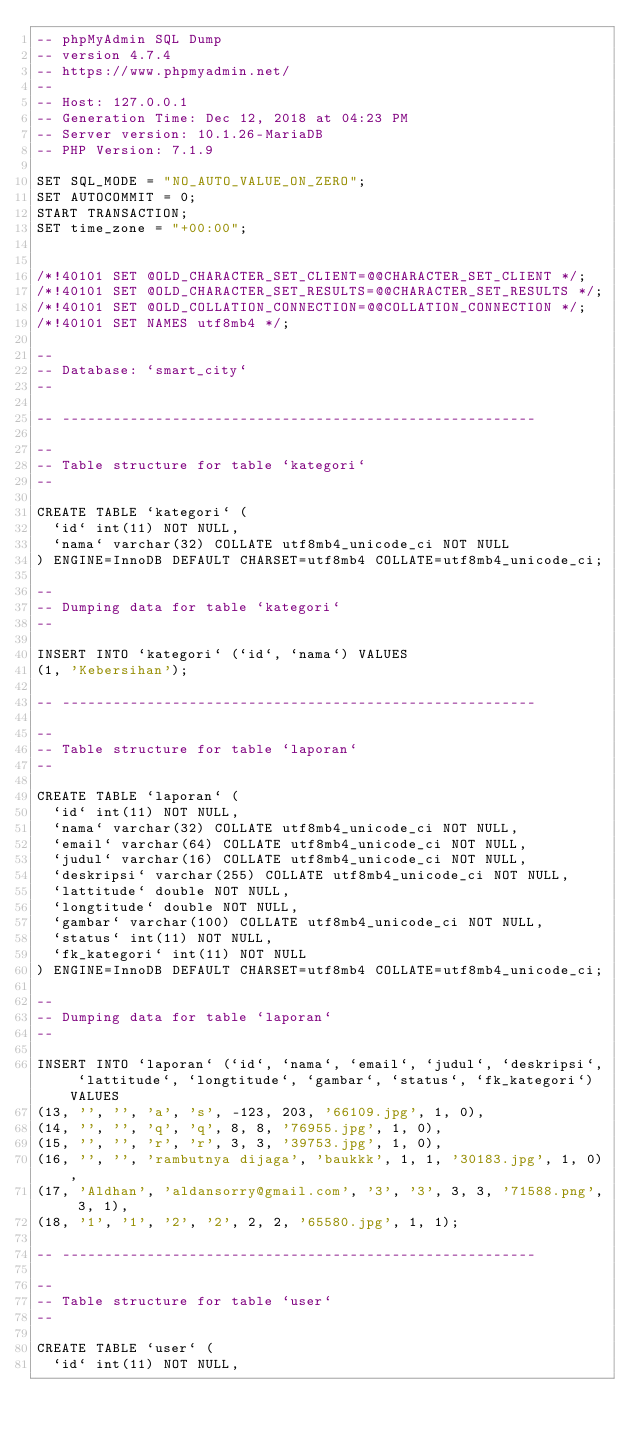Convert code to text. <code><loc_0><loc_0><loc_500><loc_500><_SQL_>-- phpMyAdmin SQL Dump
-- version 4.7.4
-- https://www.phpmyadmin.net/
--
-- Host: 127.0.0.1
-- Generation Time: Dec 12, 2018 at 04:23 PM
-- Server version: 10.1.26-MariaDB
-- PHP Version: 7.1.9

SET SQL_MODE = "NO_AUTO_VALUE_ON_ZERO";
SET AUTOCOMMIT = 0;
START TRANSACTION;
SET time_zone = "+00:00";


/*!40101 SET @OLD_CHARACTER_SET_CLIENT=@@CHARACTER_SET_CLIENT */;
/*!40101 SET @OLD_CHARACTER_SET_RESULTS=@@CHARACTER_SET_RESULTS */;
/*!40101 SET @OLD_COLLATION_CONNECTION=@@COLLATION_CONNECTION */;
/*!40101 SET NAMES utf8mb4 */;

--
-- Database: `smart_city`
--

-- --------------------------------------------------------

--
-- Table structure for table `kategori`
--

CREATE TABLE `kategori` (
  `id` int(11) NOT NULL,
  `nama` varchar(32) COLLATE utf8mb4_unicode_ci NOT NULL
) ENGINE=InnoDB DEFAULT CHARSET=utf8mb4 COLLATE=utf8mb4_unicode_ci;

--
-- Dumping data for table `kategori`
--

INSERT INTO `kategori` (`id`, `nama`) VALUES
(1, 'Kebersihan');

-- --------------------------------------------------------

--
-- Table structure for table `laporan`
--

CREATE TABLE `laporan` (
  `id` int(11) NOT NULL,
  `nama` varchar(32) COLLATE utf8mb4_unicode_ci NOT NULL,
  `email` varchar(64) COLLATE utf8mb4_unicode_ci NOT NULL,
  `judul` varchar(16) COLLATE utf8mb4_unicode_ci NOT NULL,
  `deskripsi` varchar(255) COLLATE utf8mb4_unicode_ci NOT NULL,
  `lattitude` double NOT NULL,
  `longtitude` double NOT NULL,
  `gambar` varchar(100) COLLATE utf8mb4_unicode_ci NOT NULL,
  `status` int(11) NOT NULL,
  `fk_kategori` int(11) NOT NULL
) ENGINE=InnoDB DEFAULT CHARSET=utf8mb4 COLLATE=utf8mb4_unicode_ci;

--
-- Dumping data for table `laporan`
--

INSERT INTO `laporan` (`id`, `nama`, `email`, `judul`, `deskripsi`, `lattitude`, `longtitude`, `gambar`, `status`, `fk_kategori`) VALUES
(13, '', '', 'a', 's', -123, 203, '66109.jpg', 1, 0),
(14, '', '', 'q', 'q', 8, 8, '76955.jpg', 1, 0),
(15, '', '', 'r', 'r', 3, 3, '39753.jpg', 1, 0),
(16, '', '', 'rambutnya dijaga', 'baukkk', 1, 1, '30183.jpg', 1, 0),
(17, 'Aldhan', 'aldansorry@gmail.com', '3', '3', 3, 3, '71588.png', 3, 1),
(18, '1', '1', '2', '2', 2, 2, '65580.jpg', 1, 1);

-- --------------------------------------------------------

--
-- Table structure for table `user`
--

CREATE TABLE `user` (
  `id` int(11) NOT NULL,</code> 